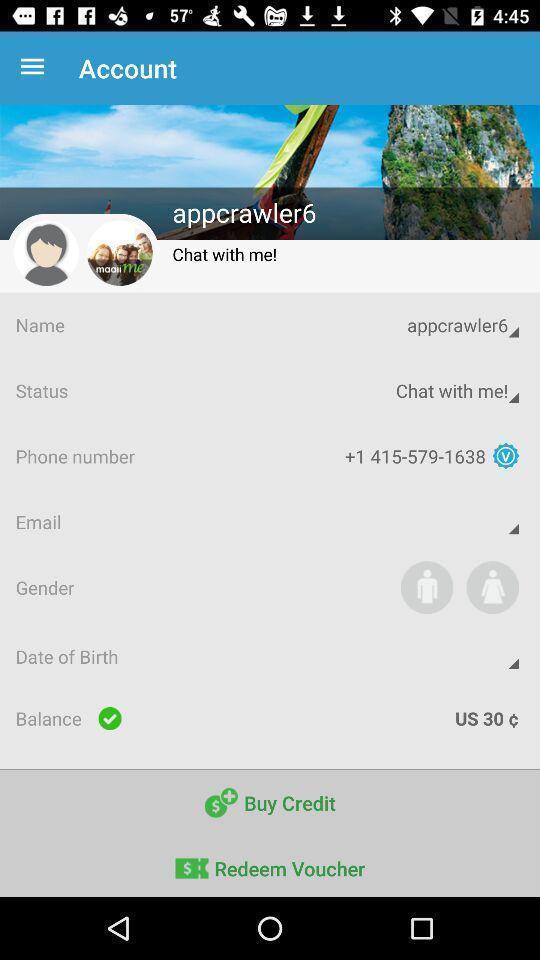Describe the key features of this screenshot. Page showing different information about profile. 